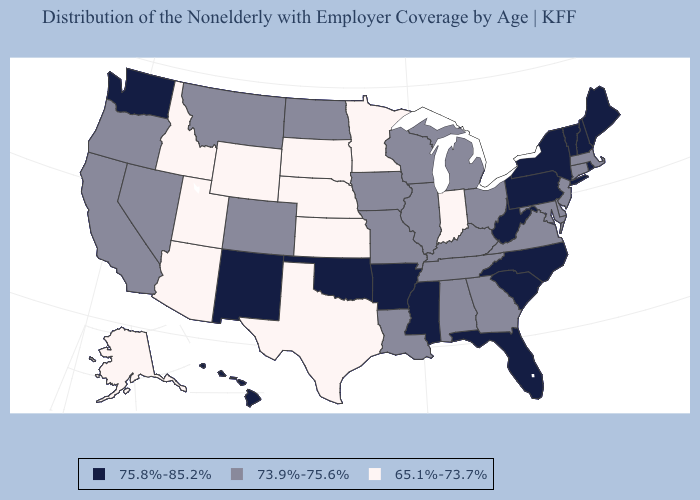Among the states that border Maine , which have the lowest value?
Answer briefly. New Hampshire. Among the states that border Arkansas , does Tennessee have the lowest value?
Keep it brief. No. Does Georgia have a higher value than Minnesota?
Keep it brief. Yes. What is the lowest value in states that border Michigan?
Quick response, please. 65.1%-73.7%. What is the lowest value in the South?
Quick response, please. 65.1%-73.7%. Does Oregon have the lowest value in the USA?
Quick response, please. No. Name the states that have a value in the range 75.8%-85.2%?
Keep it brief. Arkansas, Florida, Hawaii, Maine, Mississippi, New Hampshire, New Mexico, New York, North Carolina, Oklahoma, Pennsylvania, Rhode Island, South Carolina, Vermont, Washington, West Virginia. What is the highest value in the USA?
Keep it brief. 75.8%-85.2%. Name the states that have a value in the range 65.1%-73.7%?
Keep it brief. Alaska, Arizona, Idaho, Indiana, Kansas, Minnesota, Nebraska, South Dakota, Texas, Utah, Wyoming. Name the states that have a value in the range 73.9%-75.6%?
Concise answer only. Alabama, California, Colorado, Connecticut, Delaware, Georgia, Illinois, Iowa, Kentucky, Louisiana, Maryland, Massachusetts, Michigan, Missouri, Montana, Nevada, New Jersey, North Dakota, Ohio, Oregon, Tennessee, Virginia, Wisconsin. What is the lowest value in the USA?
Quick response, please. 65.1%-73.7%. Name the states that have a value in the range 75.8%-85.2%?
Give a very brief answer. Arkansas, Florida, Hawaii, Maine, Mississippi, New Hampshire, New Mexico, New York, North Carolina, Oklahoma, Pennsylvania, Rhode Island, South Carolina, Vermont, Washington, West Virginia. Does Connecticut have the lowest value in the USA?
Give a very brief answer. No. Name the states that have a value in the range 75.8%-85.2%?
Answer briefly. Arkansas, Florida, Hawaii, Maine, Mississippi, New Hampshire, New Mexico, New York, North Carolina, Oklahoma, Pennsylvania, Rhode Island, South Carolina, Vermont, Washington, West Virginia. Does Mississippi have the same value as Pennsylvania?
Quick response, please. Yes. 